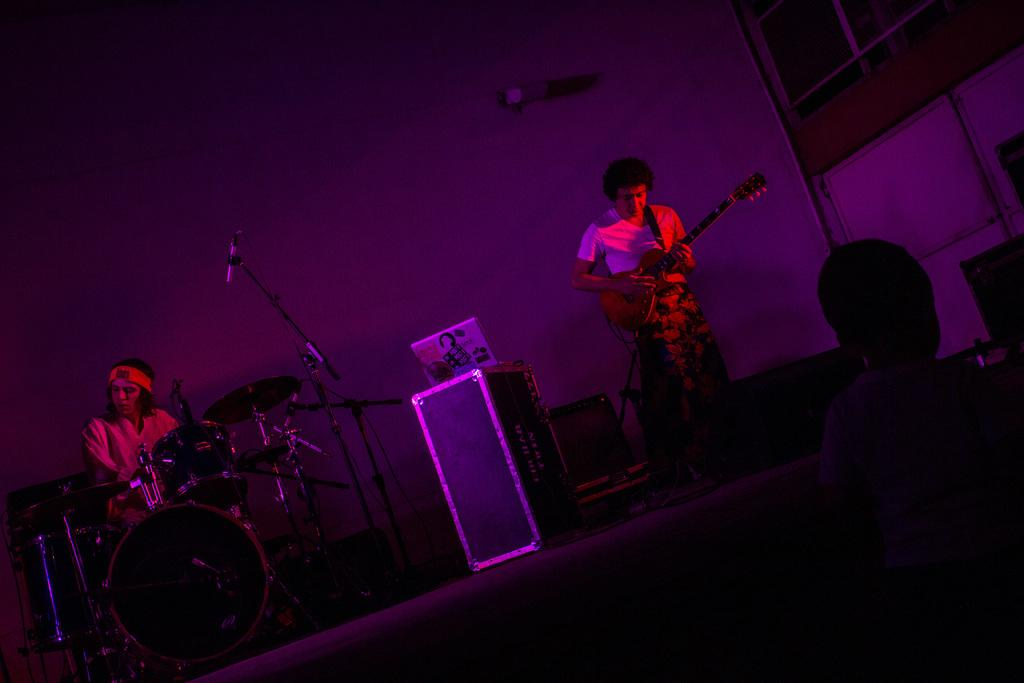How many people are performing music in the image? There are two men in the image performing music. What instruments are the men playing? One man is playing a guitar, and the other man is playing drums. Where are the musicians performing? The men are performing music on a stage. How many sticks are being used by the musicians in the image? There is no mention of sticks being used by the musicians in the image. The man playing drums is using drumsticks, but they are not visible in the image. 